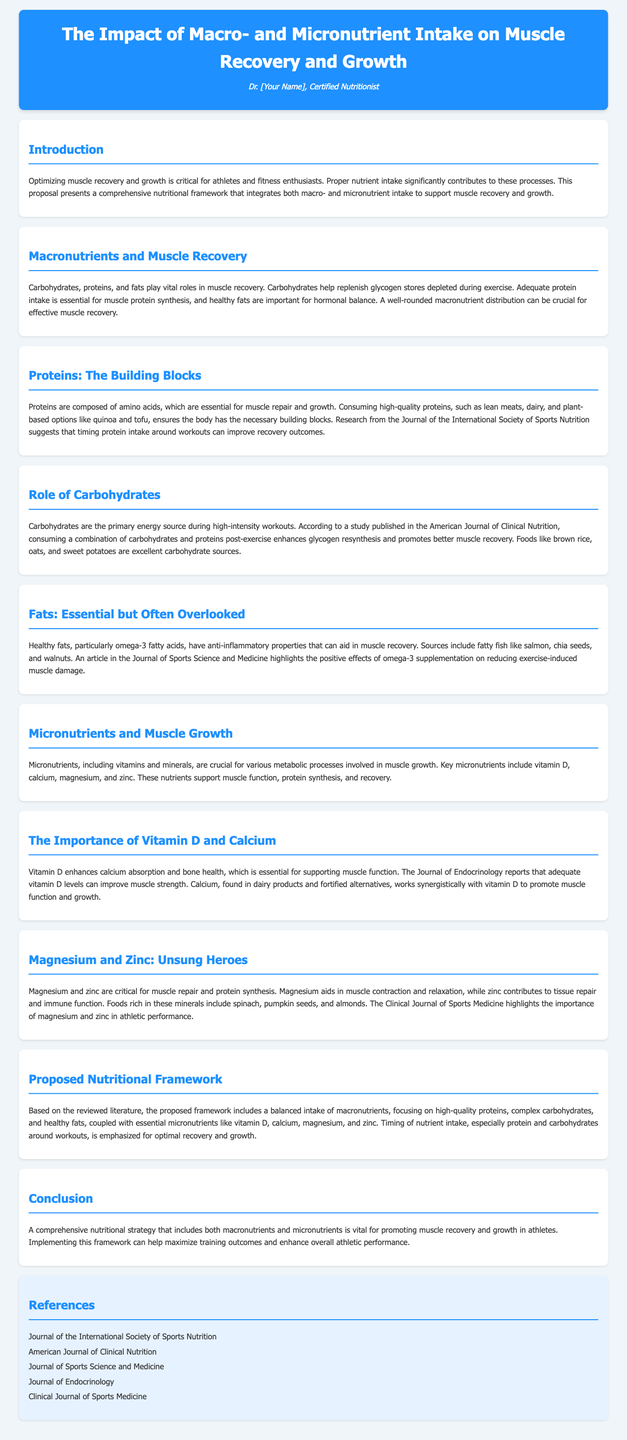What is the title of the proposal? The title is clearly stated at the top of the document.
Answer: The Impact of Macro- and Micronutrient Intake on Muscle Recovery and Growth Who is the author of the proposal? The author's name is mentioned in the header section.
Answer: Dr. [Your Name] What are the three macronutrients discussed in relation to muscle recovery? The proposal lists the macronutrients involved in recovery.
Answer: Carbohydrates, proteins, and fats Which micronutrient is highlighted for its role in calcium absorption? The document specifically mentions a micronutrient that enhances calcium absorption.
Answer: Vitamin D What type of fats are emphasized in the proposal? The section discusses the importance of a specific type of fat.
Answer: Healthy fats According to the proposal, which food is an excellent source of carbohydrates? A specific carbohydrate source is mentioned as beneficial for recovery.
Answer: Brown rice What is stated about the timing of nutrient intake? The document emphasizes a particular aspect of nutrient intake concerning exercise.
Answer: Timing of nutrient intake Which journal reported on the effects of magnesium and zinc? The proposal refers to a specific journal that covers these minerals.
Answer: Clinical Journal of Sports Medicine What is the main focus of the proposed nutritional framework? The document outlines the primary objective of the nutritional strategy.
Answer: Balanced intake of macronutrients and micronutrients 